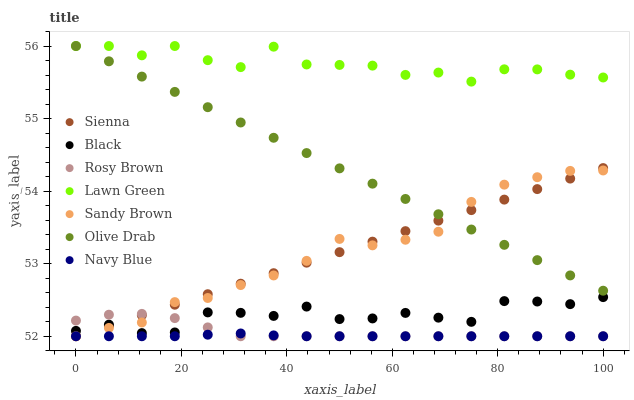Does Navy Blue have the minimum area under the curve?
Answer yes or no. Yes. Does Lawn Green have the maximum area under the curve?
Answer yes or no. Yes. Does Rosy Brown have the minimum area under the curve?
Answer yes or no. No. Does Rosy Brown have the maximum area under the curve?
Answer yes or no. No. Is Sienna the smoothest?
Answer yes or no. Yes. Is Lawn Green the roughest?
Answer yes or no. Yes. Is Navy Blue the smoothest?
Answer yes or no. No. Is Navy Blue the roughest?
Answer yes or no. No. Does Navy Blue have the lowest value?
Answer yes or no. Yes. Does Black have the lowest value?
Answer yes or no. No. Does Olive Drab have the highest value?
Answer yes or no. Yes. Does Rosy Brown have the highest value?
Answer yes or no. No. Is Navy Blue less than Olive Drab?
Answer yes or no. Yes. Is Olive Drab greater than Black?
Answer yes or no. Yes. Does Olive Drab intersect Lawn Green?
Answer yes or no. Yes. Is Olive Drab less than Lawn Green?
Answer yes or no. No. Is Olive Drab greater than Lawn Green?
Answer yes or no. No. Does Navy Blue intersect Olive Drab?
Answer yes or no. No. 